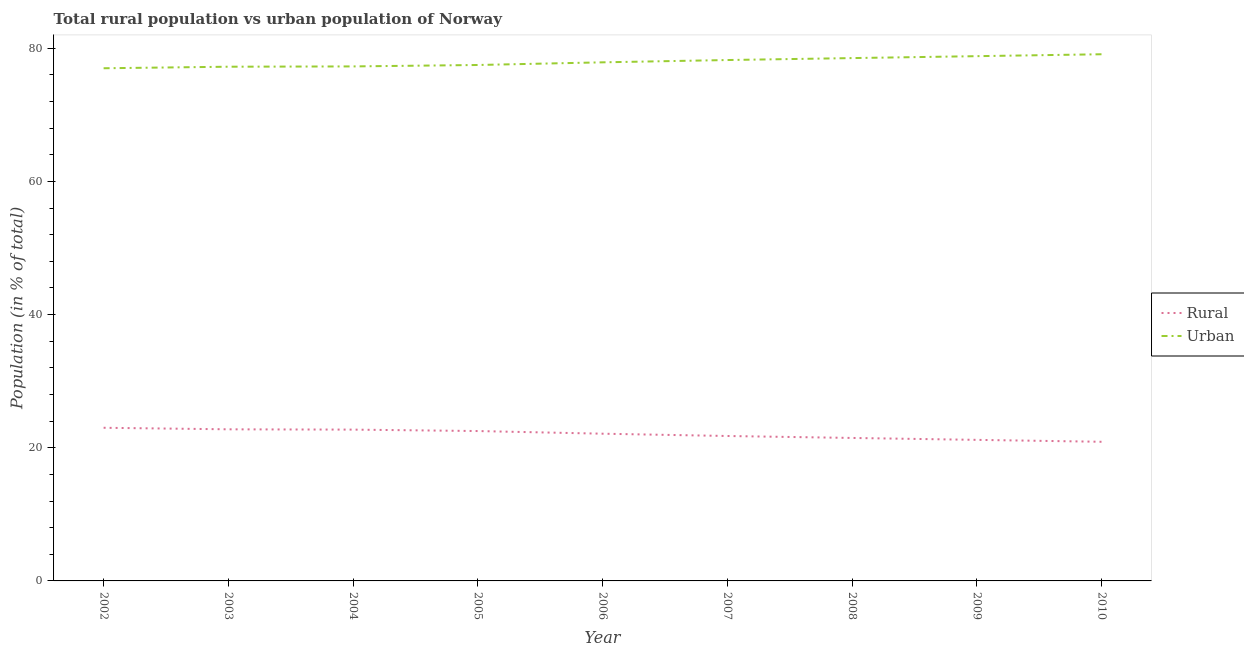Is the number of lines equal to the number of legend labels?
Ensure brevity in your answer.  Yes. What is the urban population in 2006?
Keep it short and to the point. 77.89. Across all years, what is the maximum urban population?
Your answer should be compact. 79.1. Across all years, what is the minimum rural population?
Your answer should be compact. 20.9. In which year was the rural population maximum?
Provide a succinct answer. 2002. What is the total rural population in the graph?
Keep it short and to the point. 198.44. What is the difference between the urban population in 2004 and that in 2010?
Offer a very short reply. -1.83. What is the difference between the urban population in 2002 and the rural population in 2009?
Your answer should be very brief. 55.81. What is the average urban population per year?
Your answer should be very brief. 77.95. In the year 2009, what is the difference between the rural population and urban population?
Your response must be concise. -57.63. In how many years, is the rural population greater than 4 %?
Keep it short and to the point. 9. What is the ratio of the rural population in 2005 to that in 2006?
Provide a succinct answer. 1.02. What is the difference between the highest and the second highest urban population?
Offer a very short reply. 0.29. What is the difference between the highest and the lowest urban population?
Offer a very short reply. 2.1. In how many years, is the rural population greater than the average rural population taken over all years?
Keep it short and to the point. 5. Is the sum of the rural population in 2004 and 2007 greater than the maximum urban population across all years?
Provide a short and direct response. No. Is the rural population strictly greater than the urban population over the years?
Offer a very short reply. No. Are the values on the major ticks of Y-axis written in scientific E-notation?
Provide a short and direct response. No. Does the graph contain grids?
Offer a terse response. No. Where does the legend appear in the graph?
Keep it short and to the point. Center right. What is the title of the graph?
Offer a terse response. Total rural population vs urban population of Norway. What is the label or title of the Y-axis?
Your response must be concise. Population (in % of total). What is the Population (in % of total) in Rural in 2002?
Ensure brevity in your answer.  23. What is the Population (in % of total) of Urban in 2002?
Provide a short and direct response. 77. What is the Population (in % of total) in Rural in 2003?
Offer a very short reply. 22.77. What is the Population (in % of total) in Urban in 2003?
Make the answer very short. 77.23. What is the Population (in % of total) in Rural in 2004?
Offer a very short reply. 22.73. What is the Population (in % of total) in Urban in 2004?
Your response must be concise. 77.28. What is the Population (in % of total) of Rural in 2005?
Offer a terse response. 22.51. What is the Population (in % of total) of Urban in 2005?
Ensure brevity in your answer.  77.49. What is the Population (in % of total) of Rural in 2006?
Provide a succinct answer. 22.11. What is the Population (in % of total) in Urban in 2006?
Offer a terse response. 77.89. What is the Population (in % of total) in Rural in 2007?
Provide a succinct answer. 21.77. What is the Population (in % of total) in Urban in 2007?
Make the answer very short. 78.23. What is the Population (in % of total) in Rural in 2008?
Keep it short and to the point. 21.47. What is the Population (in % of total) in Urban in 2008?
Give a very brief answer. 78.53. What is the Population (in % of total) of Rural in 2009?
Keep it short and to the point. 21.18. What is the Population (in % of total) of Urban in 2009?
Provide a succinct answer. 78.81. What is the Population (in % of total) in Rural in 2010?
Your answer should be very brief. 20.9. What is the Population (in % of total) of Urban in 2010?
Your answer should be very brief. 79.1. Across all years, what is the maximum Population (in % of total) in Rural?
Give a very brief answer. 23. Across all years, what is the maximum Population (in % of total) in Urban?
Give a very brief answer. 79.1. Across all years, what is the minimum Population (in % of total) of Rural?
Ensure brevity in your answer.  20.9. Across all years, what is the minimum Population (in % of total) in Urban?
Give a very brief answer. 77. What is the total Population (in % of total) in Rural in the graph?
Provide a short and direct response. 198.44. What is the total Population (in % of total) in Urban in the graph?
Your answer should be compact. 701.56. What is the difference between the Population (in % of total) of Rural in 2002 and that in 2003?
Offer a terse response. 0.23. What is the difference between the Population (in % of total) in Urban in 2002 and that in 2003?
Offer a terse response. -0.23. What is the difference between the Population (in % of total) of Rural in 2002 and that in 2004?
Your response must be concise. 0.28. What is the difference between the Population (in % of total) in Urban in 2002 and that in 2004?
Offer a very short reply. -0.28. What is the difference between the Population (in % of total) in Rural in 2002 and that in 2005?
Provide a succinct answer. 0.49. What is the difference between the Population (in % of total) in Urban in 2002 and that in 2005?
Provide a succinct answer. -0.49. What is the difference between the Population (in % of total) in Rural in 2002 and that in 2006?
Offer a very short reply. 0.89. What is the difference between the Population (in % of total) of Urban in 2002 and that in 2006?
Offer a very short reply. -0.89. What is the difference between the Population (in % of total) of Rural in 2002 and that in 2007?
Give a very brief answer. 1.24. What is the difference between the Population (in % of total) of Urban in 2002 and that in 2007?
Offer a very short reply. -1.24. What is the difference between the Population (in % of total) in Rural in 2002 and that in 2008?
Ensure brevity in your answer.  1.53. What is the difference between the Population (in % of total) in Urban in 2002 and that in 2008?
Your response must be concise. -1.53. What is the difference between the Population (in % of total) of Rural in 2002 and that in 2009?
Keep it short and to the point. 1.82. What is the difference between the Population (in % of total) in Urban in 2002 and that in 2009?
Give a very brief answer. -1.82. What is the difference between the Population (in % of total) in Rural in 2002 and that in 2010?
Your answer should be very brief. 2.1. What is the difference between the Population (in % of total) of Urban in 2002 and that in 2010?
Offer a very short reply. -2.1. What is the difference between the Population (in % of total) of Rural in 2003 and that in 2004?
Ensure brevity in your answer.  0.04. What is the difference between the Population (in % of total) of Urban in 2003 and that in 2004?
Offer a very short reply. -0.04. What is the difference between the Population (in % of total) in Rural in 2003 and that in 2005?
Give a very brief answer. 0.26. What is the difference between the Population (in % of total) in Urban in 2003 and that in 2005?
Offer a very short reply. -0.26. What is the difference between the Population (in % of total) in Rural in 2003 and that in 2006?
Ensure brevity in your answer.  0.66. What is the difference between the Population (in % of total) of Urban in 2003 and that in 2006?
Give a very brief answer. -0.66. What is the difference between the Population (in % of total) of Rural in 2003 and that in 2007?
Ensure brevity in your answer.  1. What is the difference between the Population (in % of total) in Urban in 2003 and that in 2007?
Ensure brevity in your answer.  -1. What is the difference between the Population (in % of total) in Rural in 2003 and that in 2008?
Ensure brevity in your answer.  1.3. What is the difference between the Population (in % of total) of Urban in 2003 and that in 2008?
Keep it short and to the point. -1.3. What is the difference between the Population (in % of total) in Rural in 2003 and that in 2009?
Your answer should be compact. 1.58. What is the difference between the Population (in % of total) of Urban in 2003 and that in 2009?
Your answer should be compact. -1.58. What is the difference between the Population (in % of total) of Rural in 2003 and that in 2010?
Give a very brief answer. 1.87. What is the difference between the Population (in % of total) of Urban in 2003 and that in 2010?
Ensure brevity in your answer.  -1.87. What is the difference between the Population (in % of total) in Rural in 2004 and that in 2005?
Give a very brief answer. 0.21. What is the difference between the Population (in % of total) in Urban in 2004 and that in 2005?
Give a very brief answer. -0.21. What is the difference between the Population (in % of total) of Rural in 2004 and that in 2006?
Your answer should be very brief. 0.61. What is the difference between the Population (in % of total) in Urban in 2004 and that in 2006?
Provide a short and direct response. -0.61. What is the difference between the Population (in % of total) in Rural in 2004 and that in 2007?
Keep it short and to the point. 0.96. What is the difference between the Population (in % of total) in Urban in 2004 and that in 2007?
Make the answer very short. -0.96. What is the difference between the Population (in % of total) in Rural in 2004 and that in 2008?
Ensure brevity in your answer.  1.25. What is the difference between the Population (in % of total) of Urban in 2004 and that in 2008?
Keep it short and to the point. -1.25. What is the difference between the Population (in % of total) in Rural in 2004 and that in 2009?
Offer a terse response. 1.54. What is the difference between the Population (in % of total) of Urban in 2004 and that in 2009?
Provide a short and direct response. -1.54. What is the difference between the Population (in % of total) of Rural in 2004 and that in 2010?
Ensure brevity in your answer.  1.83. What is the difference between the Population (in % of total) of Urban in 2004 and that in 2010?
Provide a succinct answer. -1.83. What is the difference between the Population (in % of total) in Rural in 2005 and that in 2006?
Provide a succinct answer. 0.4. What is the difference between the Population (in % of total) in Urban in 2005 and that in 2006?
Your answer should be very brief. -0.4. What is the difference between the Population (in % of total) of Rural in 2005 and that in 2007?
Keep it short and to the point. 0.74. What is the difference between the Population (in % of total) in Urban in 2005 and that in 2007?
Your answer should be compact. -0.74. What is the difference between the Population (in % of total) of Rural in 2005 and that in 2008?
Your answer should be very brief. 1.04. What is the difference between the Population (in % of total) of Urban in 2005 and that in 2008?
Ensure brevity in your answer.  -1.04. What is the difference between the Population (in % of total) in Rural in 2005 and that in 2009?
Your answer should be very brief. 1.32. What is the difference between the Population (in % of total) in Urban in 2005 and that in 2009?
Ensure brevity in your answer.  -1.32. What is the difference between the Population (in % of total) of Rural in 2005 and that in 2010?
Your answer should be very brief. 1.61. What is the difference between the Population (in % of total) in Urban in 2005 and that in 2010?
Your response must be concise. -1.61. What is the difference between the Population (in % of total) in Rural in 2006 and that in 2007?
Provide a succinct answer. 0.34. What is the difference between the Population (in % of total) in Urban in 2006 and that in 2007?
Your answer should be very brief. -0.34. What is the difference between the Population (in % of total) in Rural in 2006 and that in 2008?
Make the answer very short. 0.64. What is the difference between the Population (in % of total) of Urban in 2006 and that in 2008?
Provide a short and direct response. -0.64. What is the difference between the Population (in % of total) of Rural in 2006 and that in 2009?
Offer a terse response. 0.93. What is the difference between the Population (in % of total) in Urban in 2006 and that in 2009?
Provide a succinct answer. -0.93. What is the difference between the Population (in % of total) of Rural in 2006 and that in 2010?
Ensure brevity in your answer.  1.21. What is the difference between the Population (in % of total) in Urban in 2006 and that in 2010?
Offer a terse response. -1.21. What is the difference between the Population (in % of total) in Rural in 2007 and that in 2008?
Give a very brief answer. 0.29. What is the difference between the Population (in % of total) in Urban in 2007 and that in 2008?
Your response must be concise. -0.29. What is the difference between the Population (in % of total) in Rural in 2007 and that in 2009?
Provide a succinct answer. 0.58. What is the difference between the Population (in % of total) in Urban in 2007 and that in 2009?
Provide a short and direct response. -0.58. What is the difference between the Population (in % of total) of Rural in 2007 and that in 2010?
Give a very brief answer. 0.87. What is the difference between the Population (in % of total) in Urban in 2007 and that in 2010?
Make the answer very short. -0.87. What is the difference between the Population (in % of total) in Rural in 2008 and that in 2009?
Give a very brief answer. 0.29. What is the difference between the Population (in % of total) of Urban in 2008 and that in 2009?
Provide a succinct answer. -0.29. What is the difference between the Population (in % of total) in Rural in 2008 and that in 2010?
Offer a very short reply. 0.58. What is the difference between the Population (in % of total) in Urban in 2008 and that in 2010?
Offer a very short reply. -0.58. What is the difference between the Population (in % of total) of Rural in 2009 and that in 2010?
Make the answer very short. 0.29. What is the difference between the Population (in % of total) in Urban in 2009 and that in 2010?
Give a very brief answer. -0.29. What is the difference between the Population (in % of total) of Rural in 2002 and the Population (in % of total) of Urban in 2003?
Give a very brief answer. -54.23. What is the difference between the Population (in % of total) of Rural in 2002 and the Population (in % of total) of Urban in 2004?
Make the answer very short. -54.27. What is the difference between the Population (in % of total) of Rural in 2002 and the Population (in % of total) of Urban in 2005?
Offer a terse response. -54.49. What is the difference between the Population (in % of total) in Rural in 2002 and the Population (in % of total) in Urban in 2006?
Make the answer very short. -54.89. What is the difference between the Population (in % of total) in Rural in 2002 and the Population (in % of total) in Urban in 2007?
Make the answer very short. -55.23. What is the difference between the Population (in % of total) of Rural in 2002 and the Population (in % of total) of Urban in 2008?
Make the answer very short. -55.52. What is the difference between the Population (in % of total) of Rural in 2002 and the Population (in % of total) of Urban in 2009?
Provide a short and direct response. -55.81. What is the difference between the Population (in % of total) in Rural in 2002 and the Population (in % of total) in Urban in 2010?
Your answer should be very brief. -56.1. What is the difference between the Population (in % of total) in Rural in 2003 and the Population (in % of total) in Urban in 2004?
Your answer should be very brief. -54.51. What is the difference between the Population (in % of total) in Rural in 2003 and the Population (in % of total) in Urban in 2005?
Give a very brief answer. -54.72. What is the difference between the Population (in % of total) of Rural in 2003 and the Population (in % of total) of Urban in 2006?
Offer a terse response. -55.12. What is the difference between the Population (in % of total) in Rural in 2003 and the Population (in % of total) in Urban in 2007?
Offer a terse response. -55.46. What is the difference between the Population (in % of total) in Rural in 2003 and the Population (in % of total) in Urban in 2008?
Your answer should be compact. -55.76. What is the difference between the Population (in % of total) in Rural in 2003 and the Population (in % of total) in Urban in 2009?
Provide a succinct answer. -56.05. What is the difference between the Population (in % of total) of Rural in 2003 and the Population (in % of total) of Urban in 2010?
Make the answer very short. -56.33. What is the difference between the Population (in % of total) in Rural in 2004 and the Population (in % of total) in Urban in 2005?
Make the answer very short. -54.77. What is the difference between the Population (in % of total) in Rural in 2004 and the Population (in % of total) in Urban in 2006?
Give a very brief answer. -55.16. What is the difference between the Population (in % of total) of Rural in 2004 and the Population (in % of total) of Urban in 2007?
Your answer should be compact. -55.51. What is the difference between the Population (in % of total) in Rural in 2004 and the Population (in % of total) in Urban in 2008?
Provide a short and direct response. -55.8. What is the difference between the Population (in % of total) in Rural in 2004 and the Population (in % of total) in Urban in 2009?
Make the answer very short. -56.09. What is the difference between the Population (in % of total) of Rural in 2004 and the Population (in % of total) of Urban in 2010?
Ensure brevity in your answer.  -56.38. What is the difference between the Population (in % of total) of Rural in 2005 and the Population (in % of total) of Urban in 2006?
Keep it short and to the point. -55.38. What is the difference between the Population (in % of total) in Rural in 2005 and the Population (in % of total) in Urban in 2007?
Keep it short and to the point. -55.72. What is the difference between the Population (in % of total) in Rural in 2005 and the Population (in % of total) in Urban in 2008?
Provide a succinct answer. -56.02. What is the difference between the Population (in % of total) in Rural in 2005 and the Population (in % of total) in Urban in 2009?
Your answer should be compact. -56.3. What is the difference between the Population (in % of total) in Rural in 2005 and the Population (in % of total) in Urban in 2010?
Offer a very short reply. -56.59. What is the difference between the Population (in % of total) of Rural in 2006 and the Population (in % of total) of Urban in 2007?
Provide a short and direct response. -56.12. What is the difference between the Population (in % of total) of Rural in 2006 and the Population (in % of total) of Urban in 2008?
Ensure brevity in your answer.  -56.41. What is the difference between the Population (in % of total) in Rural in 2006 and the Population (in % of total) in Urban in 2009?
Offer a terse response. -56.7. What is the difference between the Population (in % of total) of Rural in 2006 and the Population (in % of total) of Urban in 2010?
Offer a very short reply. -56.99. What is the difference between the Population (in % of total) in Rural in 2007 and the Population (in % of total) in Urban in 2008?
Your answer should be very brief. -56.76. What is the difference between the Population (in % of total) in Rural in 2007 and the Population (in % of total) in Urban in 2009?
Offer a very short reply. -57.05. What is the difference between the Population (in % of total) of Rural in 2007 and the Population (in % of total) of Urban in 2010?
Provide a short and direct response. -57.34. What is the difference between the Population (in % of total) of Rural in 2008 and the Population (in % of total) of Urban in 2009?
Ensure brevity in your answer.  -57.34. What is the difference between the Population (in % of total) in Rural in 2008 and the Population (in % of total) in Urban in 2010?
Your answer should be compact. -57.63. What is the difference between the Population (in % of total) of Rural in 2009 and the Population (in % of total) of Urban in 2010?
Your response must be concise. -57.92. What is the average Population (in % of total) of Rural per year?
Make the answer very short. 22.05. What is the average Population (in % of total) in Urban per year?
Your answer should be very brief. 77.95. In the year 2002, what is the difference between the Population (in % of total) of Rural and Population (in % of total) of Urban?
Provide a short and direct response. -54. In the year 2003, what is the difference between the Population (in % of total) of Rural and Population (in % of total) of Urban?
Provide a short and direct response. -54.46. In the year 2004, what is the difference between the Population (in % of total) of Rural and Population (in % of total) of Urban?
Your response must be concise. -54.55. In the year 2005, what is the difference between the Population (in % of total) of Rural and Population (in % of total) of Urban?
Ensure brevity in your answer.  -54.98. In the year 2006, what is the difference between the Population (in % of total) in Rural and Population (in % of total) in Urban?
Make the answer very short. -55.78. In the year 2007, what is the difference between the Population (in % of total) in Rural and Population (in % of total) in Urban?
Keep it short and to the point. -56.47. In the year 2008, what is the difference between the Population (in % of total) of Rural and Population (in % of total) of Urban?
Make the answer very short. -57.05. In the year 2009, what is the difference between the Population (in % of total) in Rural and Population (in % of total) in Urban?
Keep it short and to the point. -57.63. In the year 2010, what is the difference between the Population (in % of total) in Rural and Population (in % of total) in Urban?
Your answer should be compact. -58.2. What is the ratio of the Population (in % of total) in Rural in 2002 to that in 2003?
Your answer should be compact. 1.01. What is the ratio of the Population (in % of total) in Rural in 2002 to that in 2004?
Keep it short and to the point. 1.01. What is the ratio of the Population (in % of total) in Urban in 2002 to that in 2004?
Offer a terse response. 1. What is the ratio of the Population (in % of total) in Rural in 2002 to that in 2005?
Ensure brevity in your answer.  1.02. What is the ratio of the Population (in % of total) of Urban in 2002 to that in 2005?
Your answer should be compact. 0.99. What is the ratio of the Population (in % of total) of Rural in 2002 to that in 2006?
Your answer should be compact. 1.04. What is the ratio of the Population (in % of total) of Rural in 2002 to that in 2007?
Give a very brief answer. 1.06. What is the ratio of the Population (in % of total) in Urban in 2002 to that in 2007?
Make the answer very short. 0.98. What is the ratio of the Population (in % of total) of Rural in 2002 to that in 2008?
Provide a short and direct response. 1.07. What is the ratio of the Population (in % of total) of Urban in 2002 to that in 2008?
Ensure brevity in your answer.  0.98. What is the ratio of the Population (in % of total) in Rural in 2002 to that in 2009?
Provide a succinct answer. 1.09. What is the ratio of the Population (in % of total) in Rural in 2002 to that in 2010?
Offer a terse response. 1.1. What is the ratio of the Population (in % of total) of Urban in 2002 to that in 2010?
Provide a succinct answer. 0.97. What is the ratio of the Population (in % of total) of Rural in 2003 to that in 2004?
Offer a terse response. 1. What is the ratio of the Population (in % of total) in Rural in 2003 to that in 2005?
Provide a short and direct response. 1.01. What is the ratio of the Population (in % of total) of Urban in 2003 to that in 2005?
Your response must be concise. 1. What is the ratio of the Population (in % of total) in Rural in 2003 to that in 2006?
Provide a short and direct response. 1.03. What is the ratio of the Population (in % of total) of Urban in 2003 to that in 2006?
Provide a short and direct response. 0.99. What is the ratio of the Population (in % of total) in Rural in 2003 to that in 2007?
Provide a succinct answer. 1.05. What is the ratio of the Population (in % of total) in Urban in 2003 to that in 2007?
Your answer should be very brief. 0.99. What is the ratio of the Population (in % of total) in Rural in 2003 to that in 2008?
Provide a succinct answer. 1.06. What is the ratio of the Population (in % of total) in Urban in 2003 to that in 2008?
Provide a succinct answer. 0.98. What is the ratio of the Population (in % of total) of Rural in 2003 to that in 2009?
Provide a succinct answer. 1.07. What is the ratio of the Population (in % of total) of Urban in 2003 to that in 2009?
Ensure brevity in your answer.  0.98. What is the ratio of the Population (in % of total) of Rural in 2003 to that in 2010?
Keep it short and to the point. 1.09. What is the ratio of the Population (in % of total) of Urban in 2003 to that in 2010?
Keep it short and to the point. 0.98. What is the ratio of the Population (in % of total) of Rural in 2004 to that in 2005?
Your response must be concise. 1.01. What is the ratio of the Population (in % of total) in Rural in 2004 to that in 2006?
Give a very brief answer. 1.03. What is the ratio of the Population (in % of total) of Rural in 2004 to that in 2007?
Your answer should be very brief. 1.04. What is the ratio of the Population (in % of total) in Urban in 2004 to that in 2007?
Your answer should be very brief. 0.99. What is the ratio of the Population (in % of total) in Rural in 2004 to that in 2008?
Make the answer very short. 1.06. What is the ratio of the Population (in % of total) in Urban in 2004 to that in 2008?
Provide a succinct answer. 0.98. What is the ratio of the Population (in % of total) in Rural in 2004 to that in 2009?
Keep it short and to the point. 1.07. What is the ratio of the Population (in % of total) of Urban in 2004 to that in 2009?
Your response must be concise. 0.98. What is the ratio of the Population (in % of total) of Rural in 2004 to that in 2010?
Make the answer very short. 1.09. What is the ratio of the Population (in % of total) in Urban in 2004 to that in 2010?
Offer a terse response. 0.98. What is the ratio of the Population (in % of total) in Rural in 2005 to that in 2006?
Keep it short and to the point. 1.02. What is the ratio of the Population (in % of total) in Urban in 2005 to that in 2006?
Your response must be concise. 0.99. What is the ratio of the Population (in % of total) in Rural in 2005 to that in 2007?
Ensure brevity in your answer.  1.03. What is the ratio of the Population (in % of total) of Urban in 2005 to that in 2007?
Give a very brief answer. 0.99. What is the ratio of the Population (in % of total) of Rural in 2005 to that in 2008?
Keep it short and to the point. 1.05. What is the ratio of the Population (in % of total) of Urban in 2005 to that in 2009?
Offer a very short reply. 0.98. What is the ratio of the Population (in % of total) of Rural in 2005 to that in 2010?
Your response must be concise. 1.08. What is the ratio of the Population (in % of total) in Urban in 2005 to that in 2010?
Give a very brief answer. 0.98. What is the ratio of the Population (in % of total) in Rural in 2006 to that in 2007?
Provide a succinct answer. 1.02. What is the ratio of the Population (in % of total) in Urban in 2006 to that in 2007?
Make the answer very short. 1. What is the ratio of the Population (in % of total) of Rural in 2006 to that in 2008?
Offer a very short reply. 1.03. What is the ratio of the Population (in % of total) in Urban in 2006 to that in 2008?
Offer a very short reply. 0.99. What is the ratio of the Population (in % of total) of Rural in 2006 to that in 2009?
Your response must be concise. 1.04. What is the ratio of the Population (in % of total) in Urban in 2006 to that in 2009?
Make the answer very short. 0.99. What is the ratio of the Population (in % of total) in Rural in 2006 to that in 2010?
Provide a succinct answer. 1.06. What is the ratio of the Population (in % of total) of Urban in 2006 to that in 2010?
Make the answer very short. 0.98. What is the ratio of the Population (in % of total) in Rural in 2007 to that in 2008?
Make the answer very short. 1.01. What is the ratio of the Population (in % of total) in Urban in 2007 to that in 2008?
Make the answer very short. 1. What is the ratio of the Population (in % of total) of Rural in 2007 to that in 2009?
Provide a short and direct response. 1.03. What is the ratio of the Population (in % of total) of Urban in 2007 to that in 2009?
Keep it short and to the point. 0.99. What is the ratio of the Population (in % of total) in Rural in 2007 to that in 2010?
Offer a terse response. 1.04. What is the ratio of the Population (in % of total) of Urban in 2007 to that in 2010?
Offer a terse response. 0.99. What is the ratio of the Population (in % of total) in Rural in 2008 to that in 2009?
Your answer should be compact. 1.01. What is the ratio of the Population (in % of total) of Rural in 2008 to that in 2010?
Give a very brief answer. 1.03. What is the ratio of the Population (in % of total) of Rural in 2009 to that in 2010?
Ensure brevity in your answer.  1.01. What is the ratio of the Population (in % of total) of Urban in 2009 to that in 2010?
Provide a short and direct response. 1. What is the difference between the highest and the second highest Population (in % of total) in Rural?
Keep it short and to the point. 0.23. What is the difference between the highest and the second highest Population (in % of total) in Urban?
Offer a very short reply. 0.29. What is the difference between the highest and the lowest Population (in % of total) in Rural?
Offer a very short reply. 2.1. What is the difference between the highest and the lowest Population (in % of total) of Urban?
Offer a terse response. 2.1. 